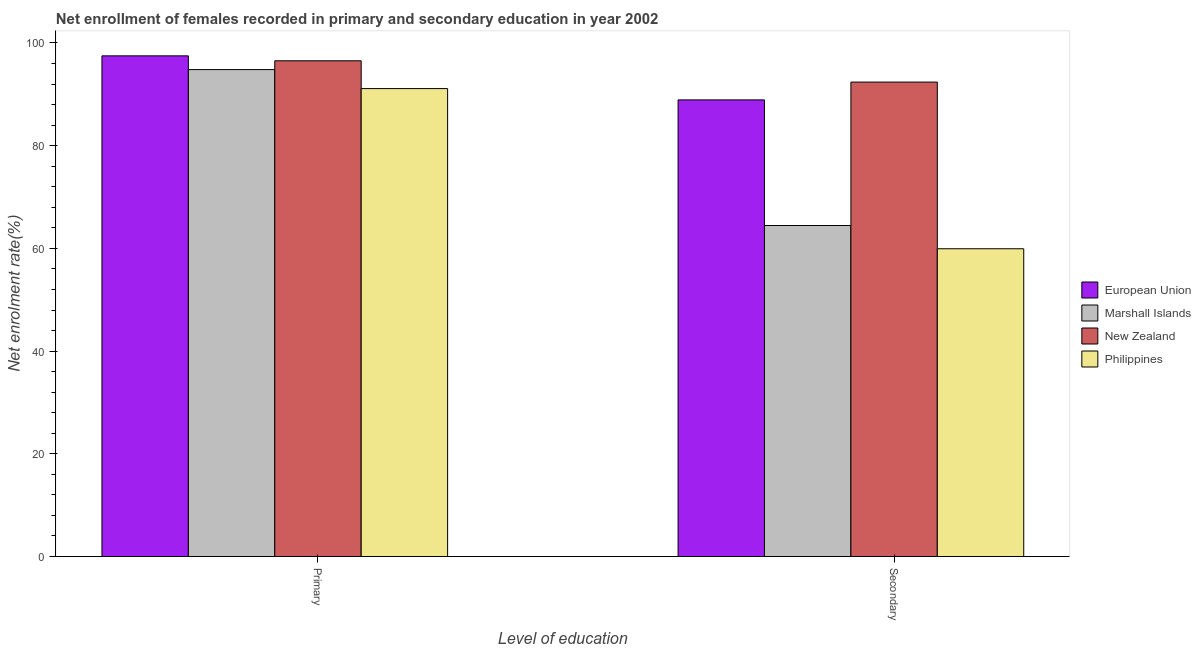How many different coloured bars are there?
Make the answer very short. 4. How many groups of bars are there?
Provide a short and direct response. 2. Are the number of bars on each tick of the X-axis equal?
Your answer should be very brief. Yes. What is the label of the 2nd group of bars from the left?
Your answer should be very brief. Secondary. What is the enrollment rate in secondary education in Philippines?
Provide a succinct answer. 59.93. Across all countries, what is the maximum enrollment rate in primary education?
Keep it short and to the point. 97.48. Across all countries, what is the minimum enrollment rate in secondary education?
Your response must be concise. 59.93. In which country was the enrollment rate in primary education maximum?
Offer a very short reply. European Union. In which country was the enrollment rate in primary education minimum?
Make the answer very short. Philippines. What is the total enrollment rate in secondary education in the graph?
Offer a very short reply. 305.67. What is the difference between the enrollment rate in primary education in Marshall Islands and that in New Zealand?
Ensure brevity in your answer.  -1.71. What is the difference between the enrollment rate in primary education in New Zealand and the enrollment rate in secondary education in European Union?
Provide a succinct answer. 7.62. What is the average enrollment rate in primary education per country?
Your answer should be very brief. 94.98. What is the difference between the enrollment rate in primary education and enrollment rate in secondary education in Philippines?
Offer a terse response. 31.19. What is the ratio of the enrollment rate in secondary education in Philippines to that in Marshall Islands?
Provide a succinct answer. 0.93. Is the enrollment rate in primary education in New Zealand less than that in Marshall Islands?
Your answer should be very brief. No. In how many countries, is the enrollment rate in secondary education greater than the average enrollment rate in secondary education taken over all countries?
Give a very brief answer. 2. What does the 3rd bar from the left in Primary represents?
Keep it short and to the point. New Zealand. What does the 4th bar from the right in Primary represents?
Give a very brief answer. European Union. How many bars are there?
Provide a short and direct response. 8. Are all the bars in the graph horizontal?
Your response must be concise. No. Does the graph contain grids?
Offer a terse response. No. How many legend labels are there?
Your answer should be compact. 4. What is the title of the graph?
Make the answer very short. Net enrollment of females recorded in primary and secondary education in year 2002. Does "Estonia" appear as one of the legend labels in the graph?
Provide a short and direct response. No. What is the label or title of the X-axis?
Provide a short and direct response. Level of education. What is the label or title of the Y-axis?
Make the answer very short. Net enrolment rate(%). What is the Net enrolment rate(%) of European Union in Primary?
Offer a terse response. 97.48. What is the Net enrolment rate(%) in Marshall Islands in Primary?
Your answer should be compact. 94.81. What is the Net enrolment rate(%) in New Zealand in Primary?
Provide a succinct answer. 96.52. What is the Net enrolment rate(%) in Philippines in Primary?
Your response must be concise. 91.11. What is the Net enrolment rate(%) of European Union in Secondary?
Keep it short and to the point. 88.91. What is the Net enrolment rate(%) of Marshall Islands in Secondary?
Your answer should be very brief. 64.45. What is the Net enrolment rate(%) in New Zealand in Secondary?
Your answer should be compact. 92.38. What is the Net enrolment rate(%) of Philippines in Secondary?
Provide a succinct answer. 59.93. Across all Level of education, what is the maximum Net enrolment rate(%) of European Union?
Your answer should be very brief. 97.48. Across all Level of education, what is the maximum Net enrolment rate(%) of Marshall Islands?
Offer a very short reply. 94.81. Across all Level of education, what is the maximum Net enrolment rate(%) in New Zealand?
Make the answer very short. 96.52. Across all Level of education, what is the maximum Net enrolment rate(%) of Philippines?
Keep it short and to the point. 91.11. Across all Level of education, what is the minimum Net enrolment rate(%) of European Union?
Offer a very short reply. 88.91. Across all Level of education, what is the minimum Net enrolment rate(%) of Marshall Islands?
Keep it short and to the point. 64.45. Across all Level of education, what is the minimum Net enrolment rate(%) of New Zealand?
Your response must be concise. 92.38. Across all Level of education, what is the minimum Net enrolment rate(%) in Philippines?
Provide a succinct answer. 59.93. What is the total Net enrolment rate(%) of European Union in the graph?
Ensure brevity in your answer.  186.39. What is the total Net enrolment rate(%) of Marshall Islands in the graph?
Make the answer very short. 159.27. What is the total Net enrolment rate(%) of New Zealand in the graph?
Keep it short and to the point. 188.9. What is the total Net enrolment rate(%) in Philippines in the graph?
Ensure brevity in your answer.  151.04. What is the difference between the Net enrolment rate(%) in European Union in Primary and that in Secondary?
Make the answer very short. 8.57. What is the difference between the Net enrolment rate(%) of Marshall Islands in Primary and that in Secondary?
Keep it short and to the point. 30.36. What is the difference between the Net enrolment rate(%) of New Zealand in Primary and that in Secondary?
Keep it short and to the point. 4.15. What is the difference between the Net enrolment rate(%) of Philippines in Primary and that in Secondary?
Give a very brief answer. 31.19. What is the difference between the Net enrolment rate(%) of European Union in Primary and the Net enrolment rate(%) of Marshall Islands in Secondary?
Your answer should be very brief. 33.03. What is the difference between the Net enrolment rate(%) of European Union in Primary and the Net enrolment rate(%) of New Zealand in Secondary?
Your answer should be very brief. 5.11. What is the difference between the Net enrolment rate(%) of European Union in Primary and the Net enrolment rate(%) of Philippines in Secondary?
Provide a succinct answer. 37.56. What is the difference between the Net enrolment rate(%) in Marshall Islands in Primary and the Net enrolment rate(%) in New Zealand in Secondary?
Your response must be concise. 2.43. What is the difference between the Net enrolment rate(%) in Marshall Islands in Primary and the Net enrolment rate(%) in Philippines in Secondary?
Keep it short and to the point. 34.89. What is the difference between the Net enrolment rate(%) in New Zealand in Primary and the Net enrolment rate(%) in Philippines in Secondary?
Make the answer very short. 36.6. What is the average Net enrolment rate(%) in European Union per Level of education?
Provide a short and direct response. 93.2. What is the average Net enrolment rate(%) in Marshall Islands per Level of education?
Make the answer very short. 79.63. What is the average Net enrolment rate(%) in New Zealand per Level of education?
Ensure brevity in your answer.  94.45. What is the average Net enrolment rate(%) in Philippines per Level of education?
Keep it short and to the point. 75.52. What is the difference between the Net enrolment rate(%) of European Union and Net enrolment rate(%) of Marshall Islands in Primary?
Give a very brief answer. 2.67. What is the difference between the Net enrolment rate(%) of European Union and Net enrolment rate(%) of New Zealand in Primary?
Keep it short and to the point. 0.96. What is the difference between the Net enrolment rate(%) in European Union and Net enrolment rate(%) in Philippines in Primary?
Ensure brevity in your answer.  6.37. What is the difference between the Net enrolment rate(%) of Marshall Islands and Net enrolment rate(%) of New Zealand in Primary?
Your answer should be very brief. -1.71. What is the difference between the Net enrolment rate(%) in Marshall Islands and Net enrolment rate(%) in Philippines in Primary?
Make the answer very short. 3.7. What is the difference between the Net enrolment rate(%) in New Zealand and Net enrolment rate(%) in Philippines in Primary?
Offer a terse response. 5.41. What is the difference between the Net enrolment rate(%) of European Union and Net enrolment rate(%) of Marshall Islands in Secondary?
Your answer should be very brief. 24.46. What is the difference between the Net enrolment rate(%) in European Union and Net enrolment rate(%) in New Zealand in Secondary?
Make the answer very short. -3.47. What is the difference between the Net enrolment rate(%) of European Union and Net enrolment rate(%) of Philippines in Secondary?
Keep it short and to the point. 28.98. What is the difference between the Net enrolment rate(%) in Marshall Islands and Net enrolment rate(%) in New Zealand in Secondary?
Your answer should be very brief. -27.92. What is the difference between the Net enrolment rate(%) in Marshall Islands and Net enrolment rate(%) in Philippines in Secondary?
Give a very brief answer. 4.53. What is the difference between the Net enrolment rate(%) in New Zealand and Net enrolment rate(%) in Philippines in Secondary?
Ensure brevity in your answer.  32.45. What is the ratio of the Net enrolment rate(%) in European Union in Primary to that in Secondary?
Your response must be concise. 1.1. What is the ratio of the Net enrolment rate(%) in Marshall Islands in Primary to that in Secondary?
Your answer should be very brief. 1.47. What is the ratio of the Net enrolment rate(%) in New Zealand in Primary to that in Secondary?
Ensure brevity in your answer.  1.04. What is the ratio of the Net enrolment rate(%) of Philippines in Primary to that in Secondary?
Offer a very short reply. 1.52. What is the difference between the highest and the second highest Net enrolment rate(%) in European Union?
Provide a short and direct response. 8.57. What is the difference between the highest and the second highest Net enrolment rate(%) in Marshall Islands?
Provide a short and direct response. 30.36. What is the difference between the highest and the second highest Net enrolment rate(%) in New Zealand?
Provide a short and direct response. 4.15. What is the difference between the highest and the second highest Net enrolment rate(%) in Philippines?
Make the answer very short. 31.19. What is the difference between the highest and the lowest Net enrolment rate(%) in European Union?
Offer a very short reply. 8.57. What is the difference between the highest and the lowest Net enrolment rate(%) in Marshall Islands?
Provide a succinct answer. 30.36. What is the difference between the highest and the lowest Net enrolment rate(%) of New Zealand?
Your answer should be very brief. 4.15. What is the difference between the highest and the lowest Net enrolment rate(%) of Philippines?
Your answer should be very brief. 31.19. 